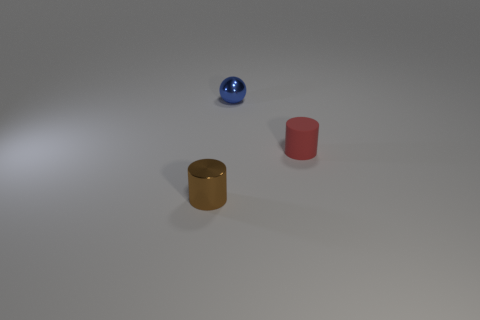How many objects are big red rubber blocks or cylinders?
Offer a very short reply. 2. What number of objects are tiny spheres or small metal things that are right of the brown metallic cylinder?
Ensure brevity in your answer.  1. Do the ball and the brown cylinder have the same material?
Your answer should be compact. Yes. How many other objects are there of the same material as the brown thing?
Your answer should be very brief. 1. Are there more brown cylinders than large yellow rubber cylinders?
Your response must be concise. Yes. Does the small metal thing that is in front of the red rubber cylinder have the same shape as the matte object?
Ensure brevity in your answer.  Yes. Are there fewer tiny green metallic blocks than tiny metallic things?
Offer a terse response. Yes. There is a red thing that is the same size as the metal cylinder; what is it made of?
Provide a short and direct response. Rubber. There is a sphere; is its color the same as the small metal object in front of the red cylinder?
Your answer should be very brief. No. Are there fewer tiny blue metal spheres that are in front of the small red cylinder than tiny red rubber things?
Provide a succinct answer. Yes. 